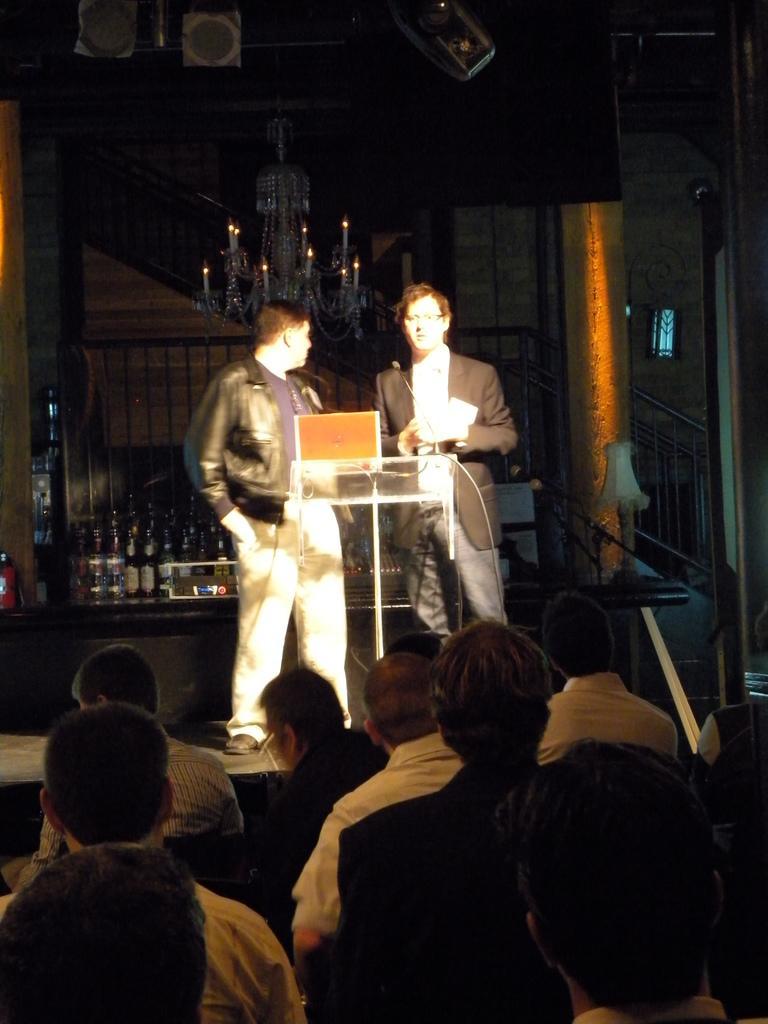Could you give a brief overview of what you see in this image? In this image we can see two persons standing on the stage in front of the podium. We can also see the people. In the background we can see the alcohol bottles on the counter. We can also see the railing, wall window and also the light hangs from the ceiling. We can also see some other objects. 